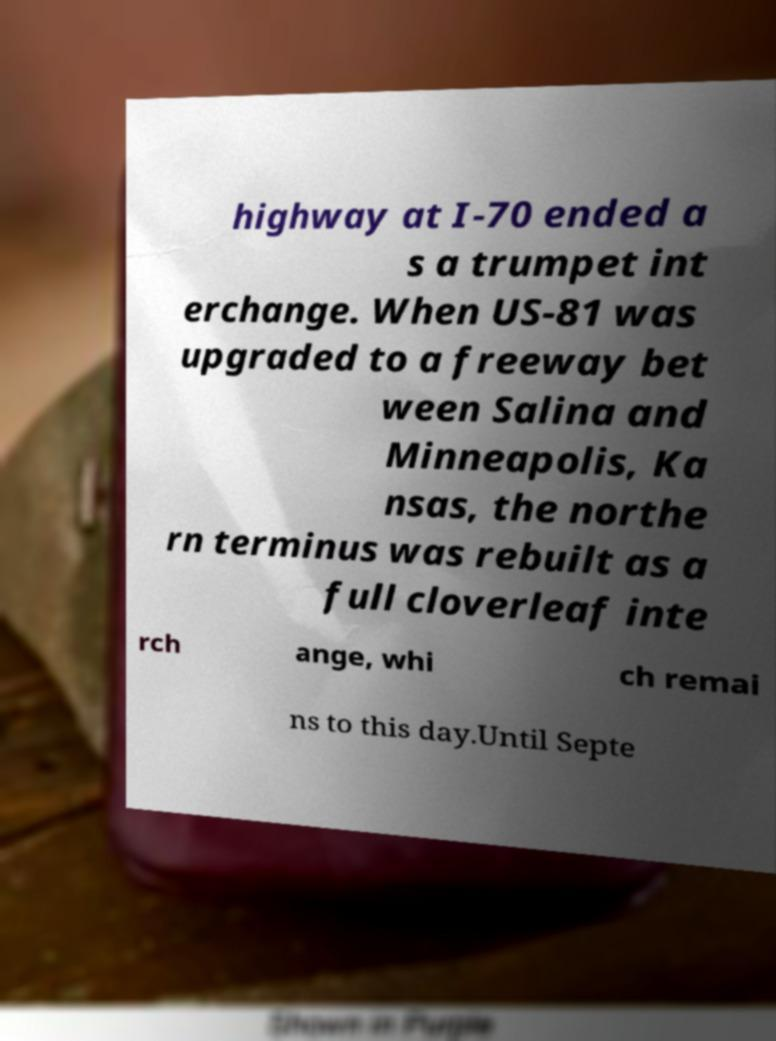Can you read and provide the text displayed in the image?This photo seems to have some interesting text. Can you extract and type it out for me? highway at I-70 ended a s a trumpet int erchange. When US-81 was upgraded to a freeway bet ween Salina and Minneapolis, Ka nsas, the northe rn terminus was rebuilt as a full cloverleaf inte rch ange, whi ch remai ns to this day.Until Septe 